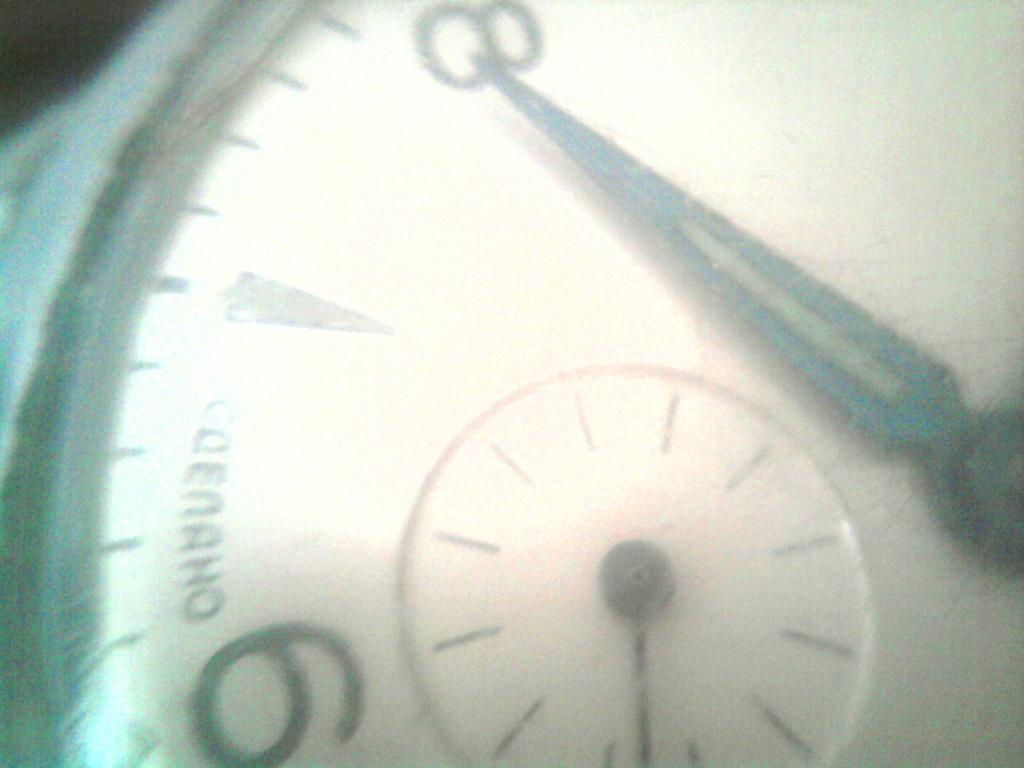<image>
Create a compact narrative representing the image presented. A watch that shows the minute hand on the number 8. 